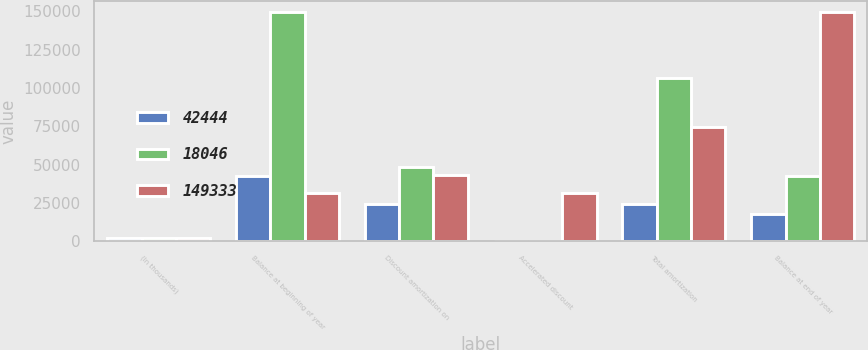Convert chart to OTSL. <chart><loc_0><loc_0><loc_500><loc_500><stacked_bar_chart><ecel><fcel>(In thousands)<fcel>Balance at beginning of year<fcel>Discount amortization on<fcel>Accelerated discount<fcel>Total amortization<fcel>Balance at end of year<nl><fcel>42444<fcel>2014<fcel>42444<fcel>24397<fcel>1<fcel>24398<fcel>18046<nl><fcel>18046<fcel>2013<fcel>149333<fcel>48378<fcel>368<fcel>106889<fcel>42444<nl><fcel>149333<fcel>2012<fcel>31532<fcel>43341<fcel>31532<fcel>74873<fcel>149333<nl></chart> 